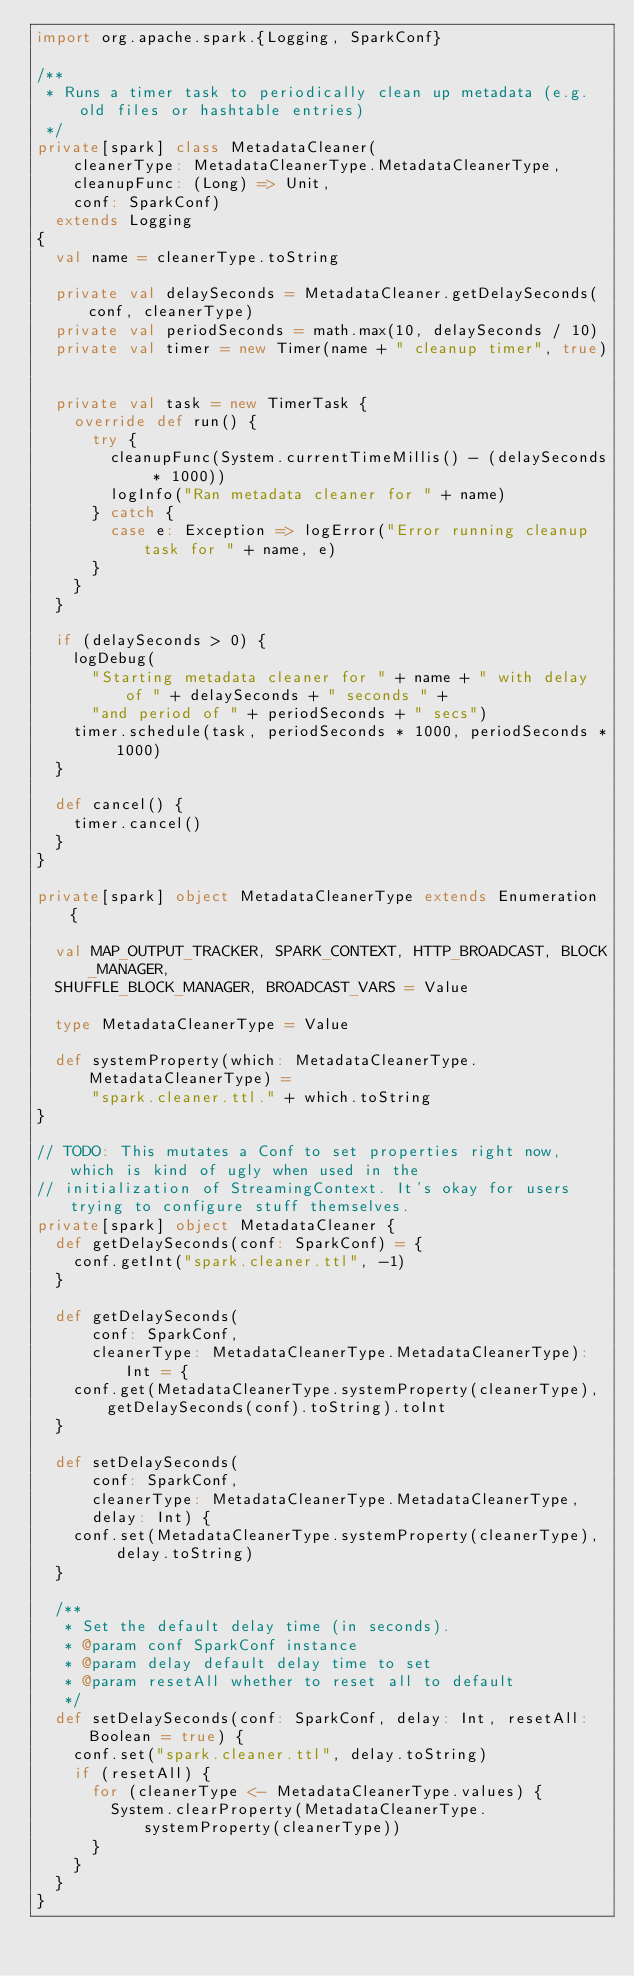<code> <loc_0><loc_0><loc_500><loc_500><_Scala_>import org.apache.spark.{Logging, SparkConf}

/**
 * Runs a timer task to periodically clean up metadata (e.g. old files or hashtable entries)
 */
private[spark] class MetadataCleaner(
    cleanerType: MetadataCleanerType.MetadataCleanerType,
    cleanupFunc: (Long) => Unit,
    conf: SparkConf)
  extends Logging
{
  val name = cleanerType.toString

  private val delaySeconds = MetadataCleaner.getDelaySeconds(conf, cleanerType)
  private val periodSeconds = math.max(10, delaySeconds / 10)
  private val timer = new Timer(name + " cleanup timer", true)


  private val task = new TimerTask {
    override def run() {
      try {
        cleanupFunc(System.currentTimeMillis() - (delaySeconds * 1000))
        logInfo("Ran metadata cleaner for " + name)
      } catch {
        case e: Exception => logError("Error running cleanup task for " + name, e)
      }
    }
  }

  if (delaySeconds > 0) {
    logDebug(
      "Starting metadata cleaner for " + name + " with delay of " + delaySeconds + " seconds " +
      "and period of " + periodSeconds + " secs")
    timer.schedule(task, periodSeconds * 1000, periodSeconds * 1000)
  }

  def cancel() {
    timer.cancel()
  }
}

private[spark] object MetadataCleanerType extends Enumeration {

  val MAP_OUTPUT_TRACKER, SPARK_CONTEXT, HTTP_BROADCAST, BLOCK_MANAGER,
  SHUFFLE_BLOCK_MANAGER, BROADCAST_VARS = Value

  type MetadataCleanerType = Value

  def systemProperty(which: MetadataCleanerType.MetadataCleanerType) =
      "spark.cleaner.ttl." + which.toString
}

// TODO: This mutates a Conf to set properties right now, which is kind of ugly when used in the
// initialization of StreamingContext. It's okay for users trying to configure stuff themselves.
private[spark] object MetadataCleaner {
  def getDelaySeconds(conf: SparkConf) = {
    conf.getInt("spark.cleaner.ttl", -1)
  }

  def getDelaySeconds(
      conf: SparkConf,
      cleanerType: MetadataCleanerType.MetadataCleanerType): Int = {
    conf.get(MetadataCleanerType.systemProperty(cleanerType), getDelaySeconds(conf).toString).toInt
  }

  def setDelaySeconds(
      conf: SparkConf,
      cleanerType: MetadataCleanerType.MetadataCleanerType,
      delay: Int) {
    conf.set(MetadataCleanerType.systemProperty(cleanerType),  delay.toString)
  }

  /**
   * Set the default delay time (in seconds).
   * @param conf SparkConf instance
   * @param delay default delay time to set
   * @param resetAll whether to reset all to default
   */
  def setDelaySeconds(conf: SparkConf, delay: Int, resetAll: Boolean = true) {
    conf.set("spark.cleaner.ttl", delay.toString)
    if (resetAll) {
      for (cleanerType <- MetadataCleanerType.values) {
        System.clearProperty(MetadataCleanerType.systemProperty(cleanerType))
      }
    }
  }
}

</code> 